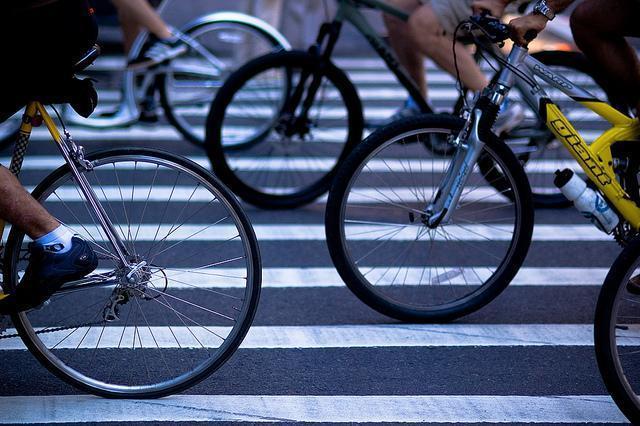How many wheels are there?
Give a very brief answer. 5. How many people are in the picture?
Give a very brief answer. 4. How many bottles can you see?
Give a very brief answer. 1. How many bicycles are there?
Give a very brief answer. 4. 